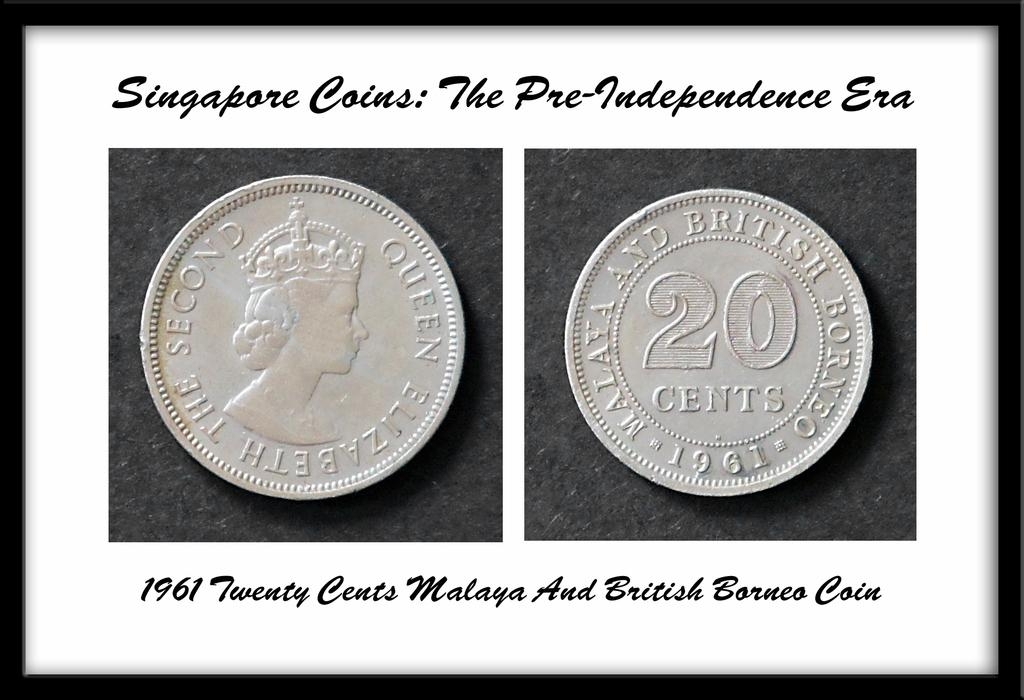<image>
Relay a brief, clear account of the picture shown. a frame of two coins that says 'signapore coins: the pre-independence era' on it 